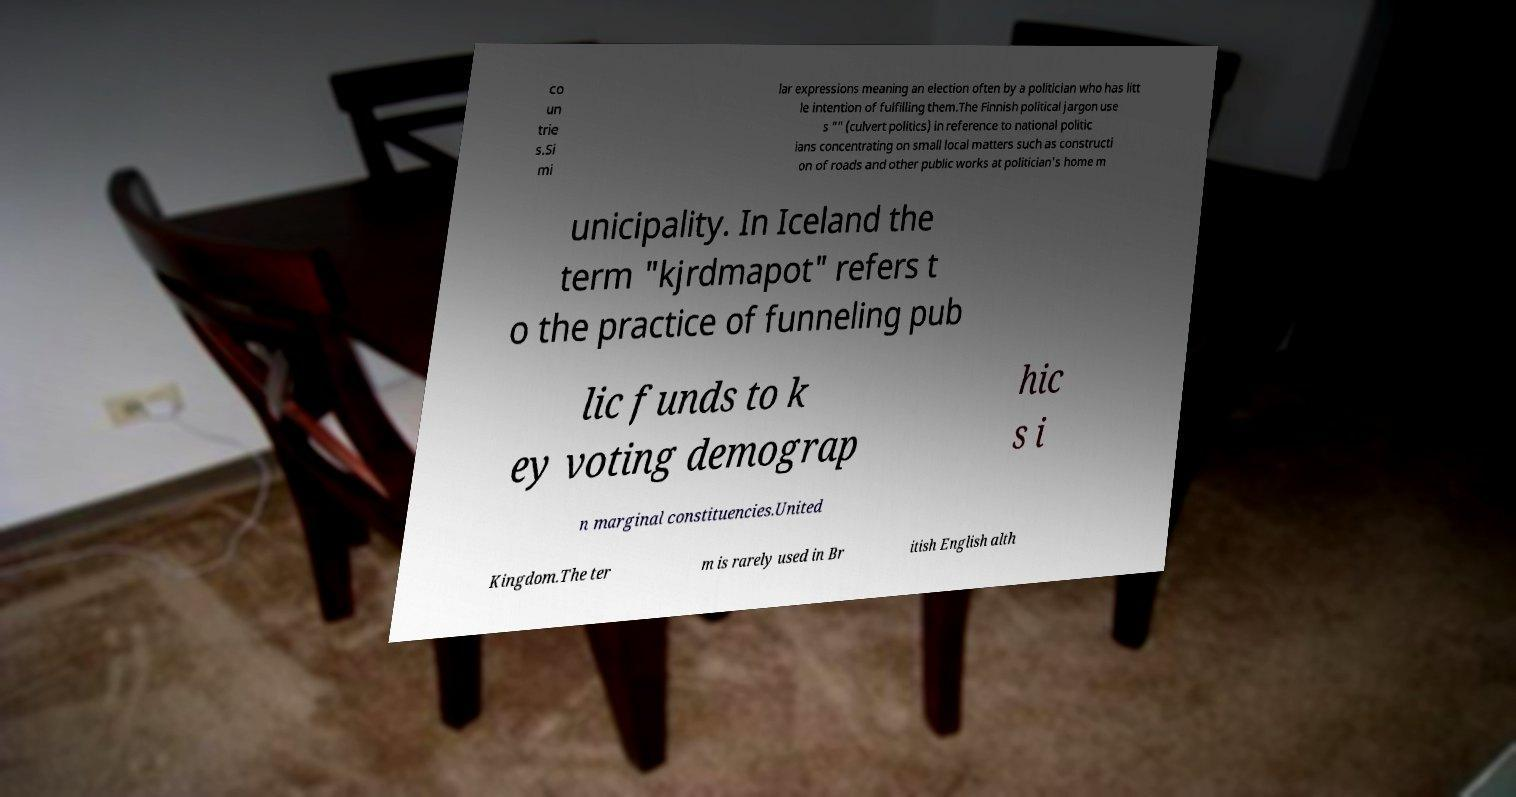For documentation purposes, I need the text within this image transcribed. Could you provide that? co un trie s.Si mi lar expressions meaning an election often by a politician who has litt le intention of fulfilling them.The Finnish political jargon use s "" (culvert politics) in reference to national politic ians concentrating on small local matters such as constructi on of roads and other public works at politician's home m unicipality. In Iceland the term "kjrdmapot" refers t o the practice of funneling pub lic funds to k ey voting demograp hic s i n marginal constituencies.United Kingdom.The ter m is rarely used in Br itish English alth 